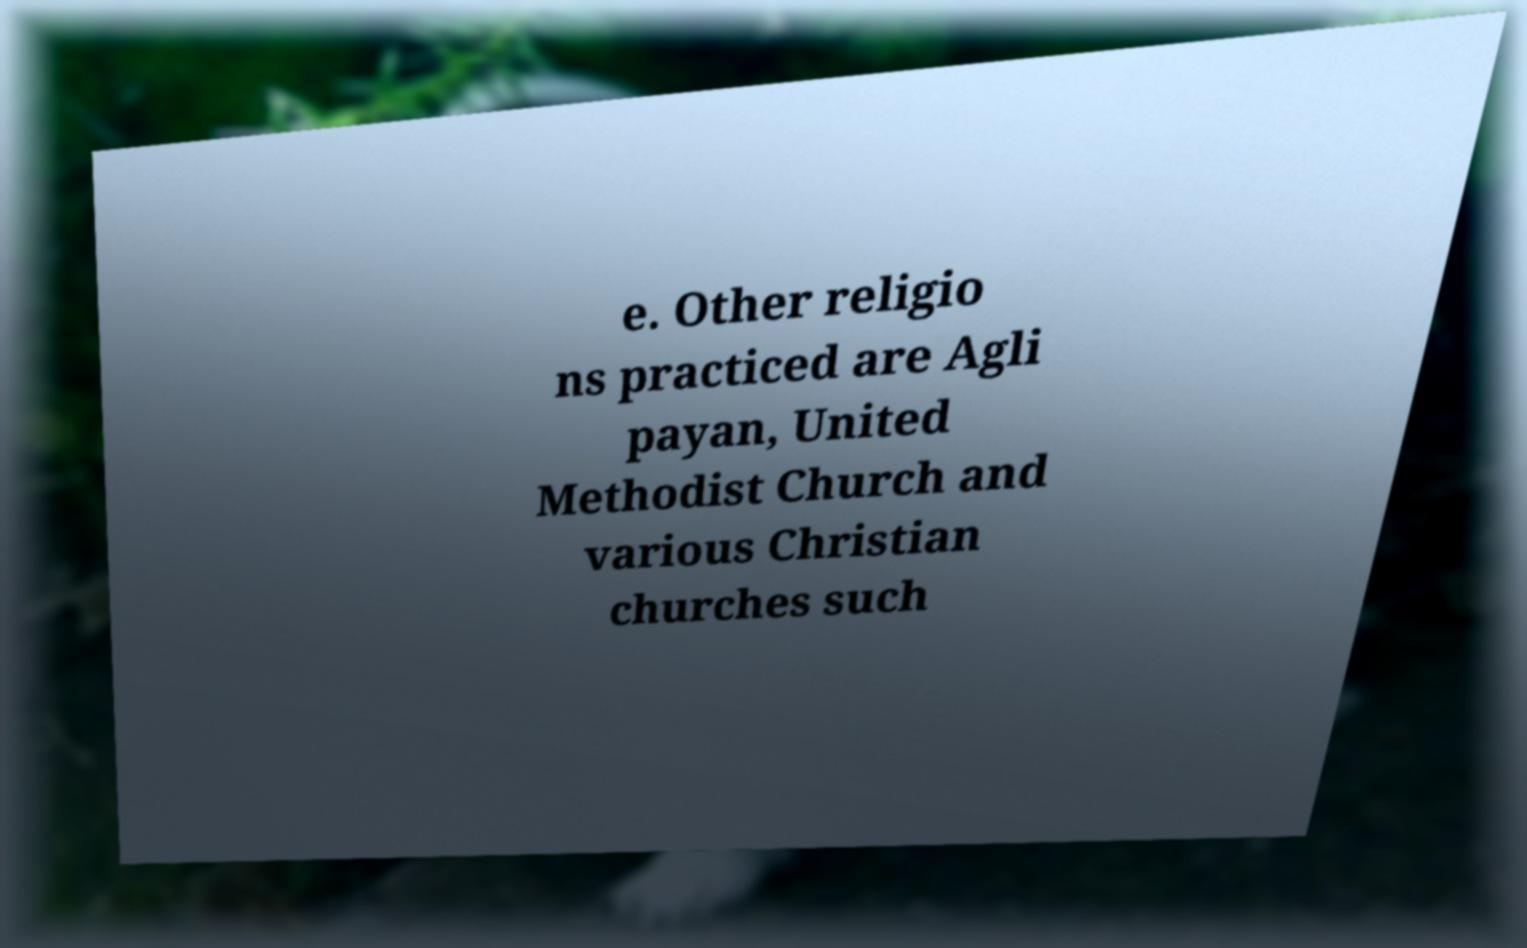Please read and relay the text visible in this image. What does it say? e. Other religio ns practiced are Agli payan, United Methodist Church and various Christian churches such 